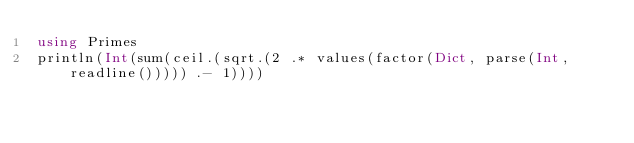<code> <loc_0><loc_0><loc_500><loc_500><_Julia_>using Primes
println(Int(sum(ceil.(sqrt.(2 .* values(factor(Dict, parse(Int, readline())))) .- 1))))</code> 